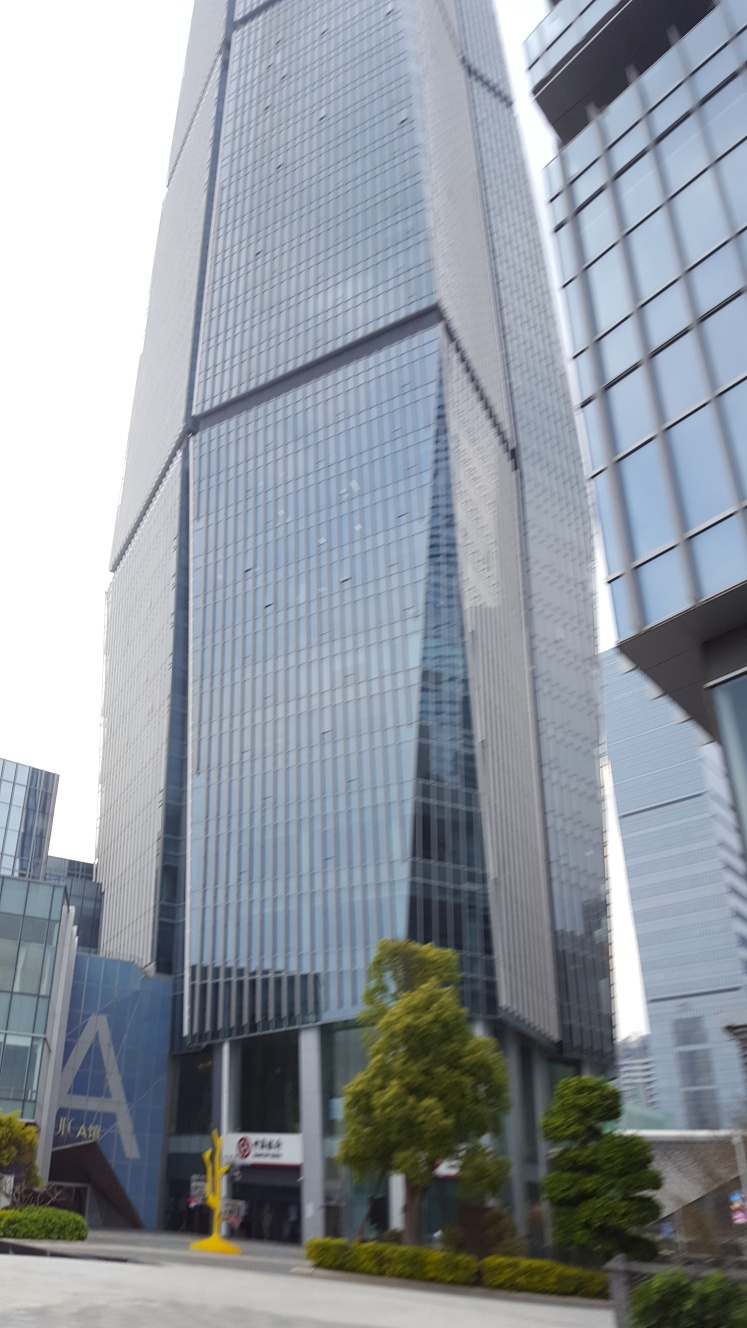Can you describe the mood or atmosphere this image evokes? The image seems to capture a sense of quiet efficiency and modernity. The tall skyscrapers, clear sky, and the absence of people in the frame suggest a tranquil cityscape, possibly early in the morning or on a weekend when the rush of corporate activity is at a pause. 